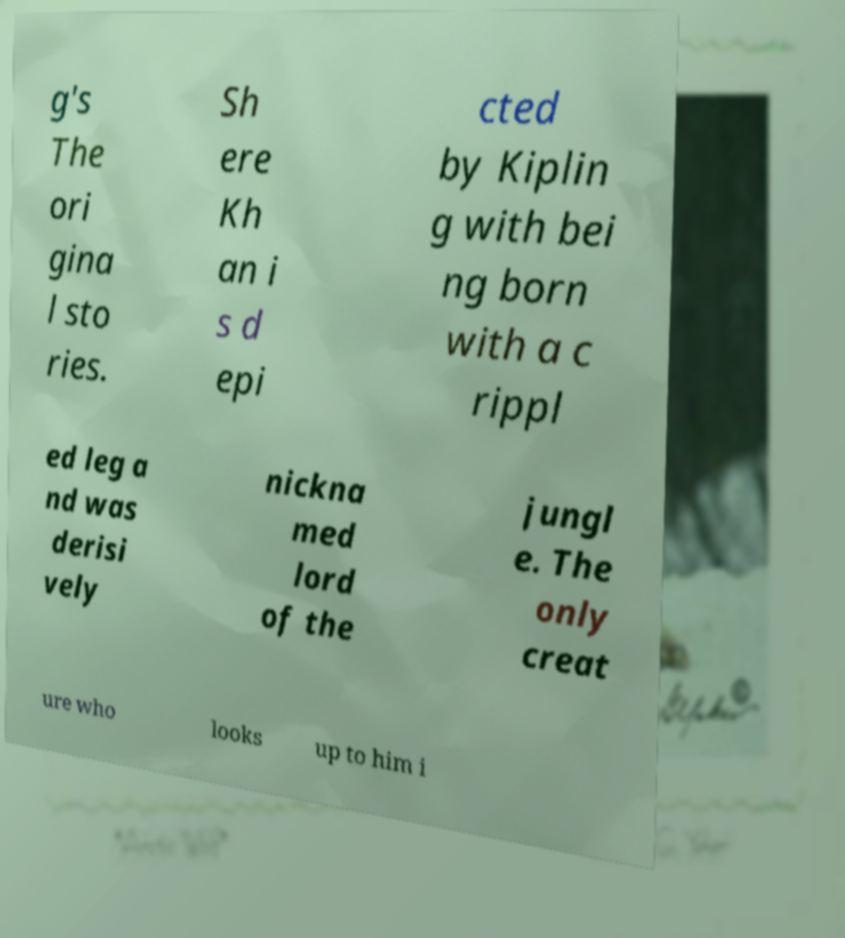Please read and relay the text visible in this image. What does it say? g's The ori gina l sto ries. Sh ere Kh an i s d epi cted by Kiplin g with bei ng born with a c rippl ed leg a nd was derisi vely nickna med lord of the jungl e. The only creat ure who looks up to him i 